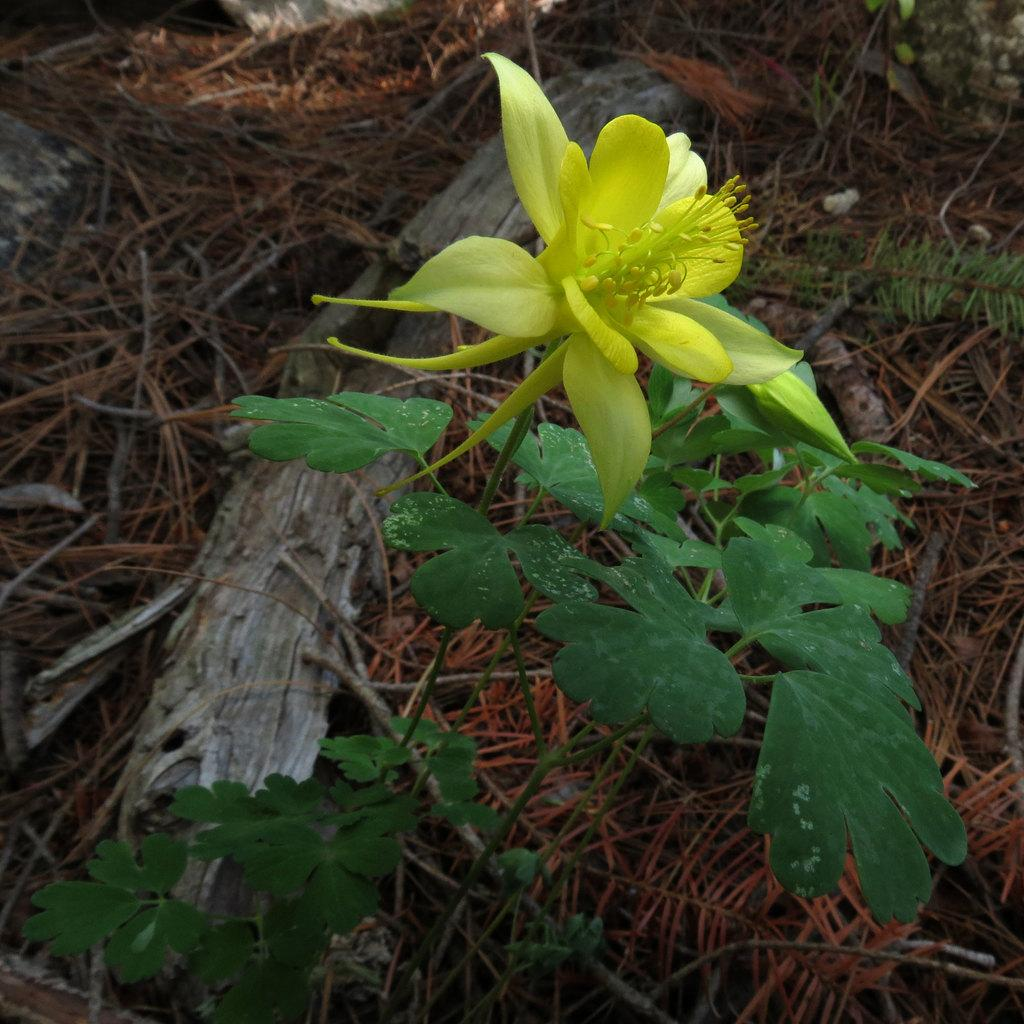What is the main subject of the image? There is a flower in the image. Are there any other plants in the image besides the flower? Yes, there are plants in the image. What is the color of the plants in the image? The plants are green in color. What can be seen in the background of the image? There is dried grass in the background of the image. What type of instrument is the rabbit playing in the image? There is no rabbit or instrument present in the image. Can you describe the pear that is hanging from the tree in the image? There is no pear or tree present in the image. 